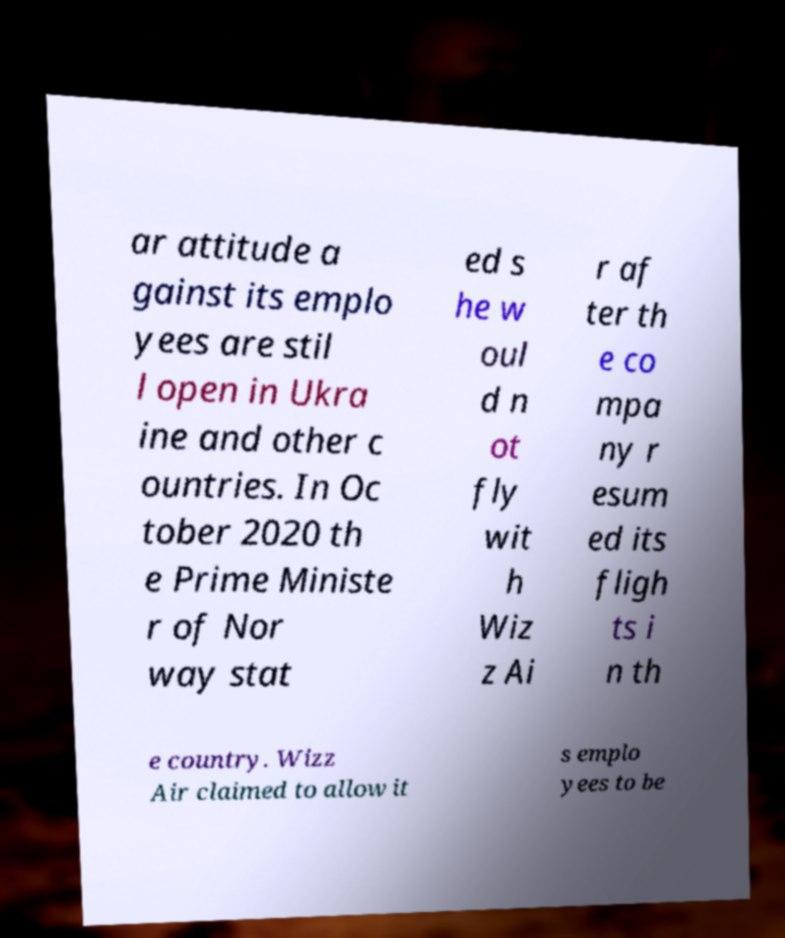Can you accurately transcribe the text from the provided image for me? ar attitude a gainst its emplo yees are stil l open in Ukra ine and other c ountries. In Oc tober 2020 th e Prime Ministe r of Nor way stat ed s he w oul d n ot fly wit h Wiz z Ai r af ter th e co mpa ny r esum ed its fligh ts i n th e country. Wizz Air claimed to allow it s emplo yees to be 